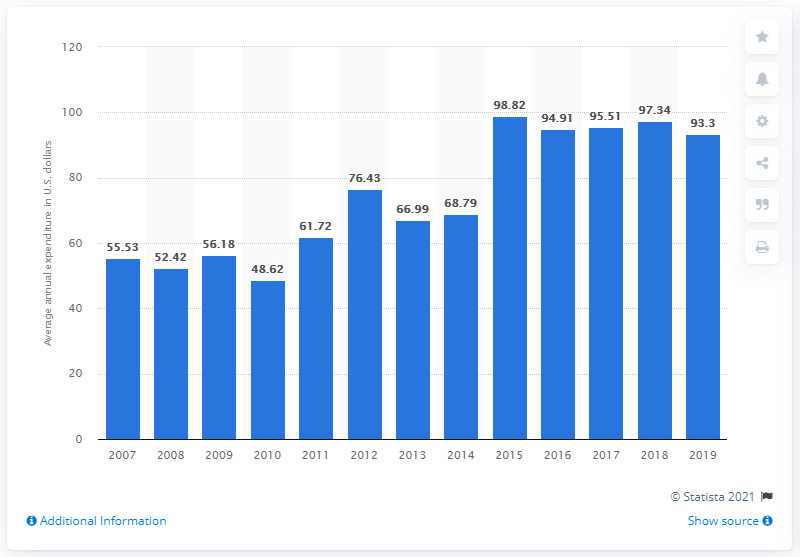Highlight a few significant elements in this photo. The average expenditure on mattresses and springs per consumer unit in the United States in 2019 was 93.3 dollars. 